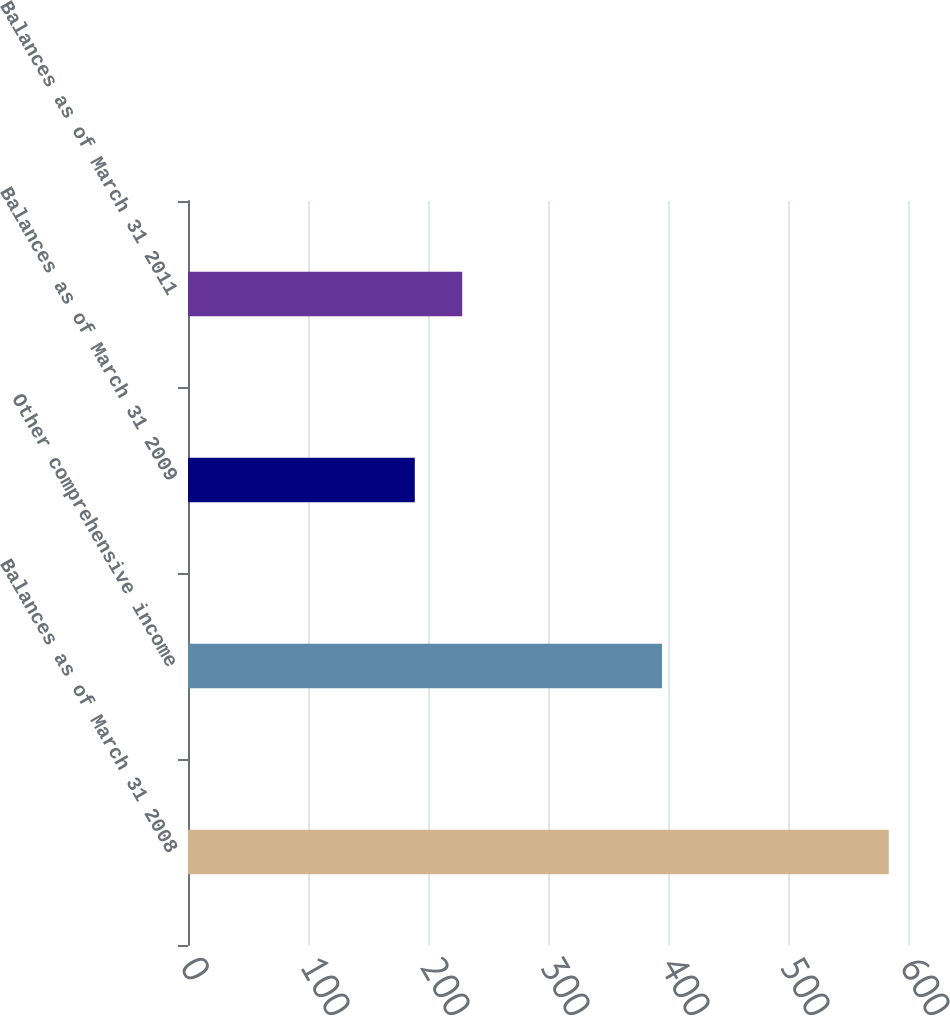Convert chart. <chart><loc_0><loc_0><loc_500><loc_500><bar_chart><fcel>Balances as of March 31 2008<fcel>Other comprehensive income<fcel>Balances as of March 31 2009<fcel>Balances as of March 31 2011<nl><fcel>584<fcel>395<fcel>189<fcel>228.5<nl></chart> 